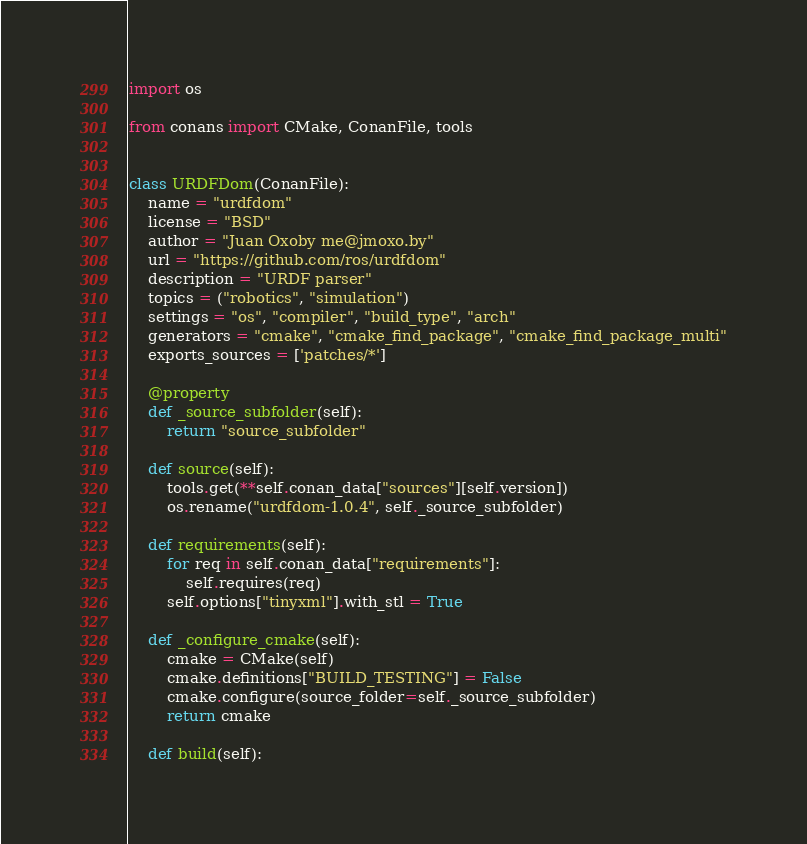<code> <loc_0><loc_0><loc_500><loc_500><_Python_>import os

from conans import CMake, ConanFile, tools


class URDFDom(ConanFile):
    name = "urdfdom"
    license = "BSD"
    author = "Juan Oxoby me@jmoxo.by"
    url = "https://github.com/ros/urdfdom"
    description = "URDF parser"
    topics = ("robotics", "simulation")
    settings = "os", "compiler", "build_type", "arch"
    generators = "cmake", "cmake_find_package", "cmake_find_package_multi"
    exports_sources = ['patches/*']

    @property
    def _source_subfolder(self):
        return "source_subfolder"

    def source(self):
        tools.get(**self.conan_data["sources"][self.version])
        os.rename("urdfdom-1.0.4", self._source_subfolder)

    def requirements(self):
        for req in self.conan_data["requirements"]:
            self.requires(req)
        self.options["tinyxml"].with_stl = True

    def _configure_cmake(self):
        cmake = CMake(self)
        cmake.definitions["BUILD_TESTING"] = False
        cmake.configure(source_folder=self._source_subfolder)
        return cmake

    def build(self):</code> 